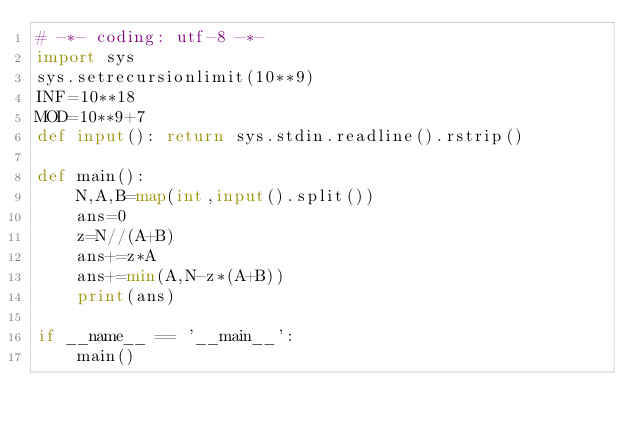<code> <loc_0><loc_0><loc_500><loc_500><_Python_># -*- coding: utf-8 -*-
import sys
sys.setrecursionlimit(10**9)
INF=10**18
MOD=10**9+7
def input(): return sys.stdin.readline().rstrip()

def main():
    N,A,B=map(int,input().split())
    ans=0
    z=N//(A+B)
    ans+=z*A
    ans+=min(A,N-z*(A+B))
    print(ans)

if __name__ == '__main__':
    main()
</code> 